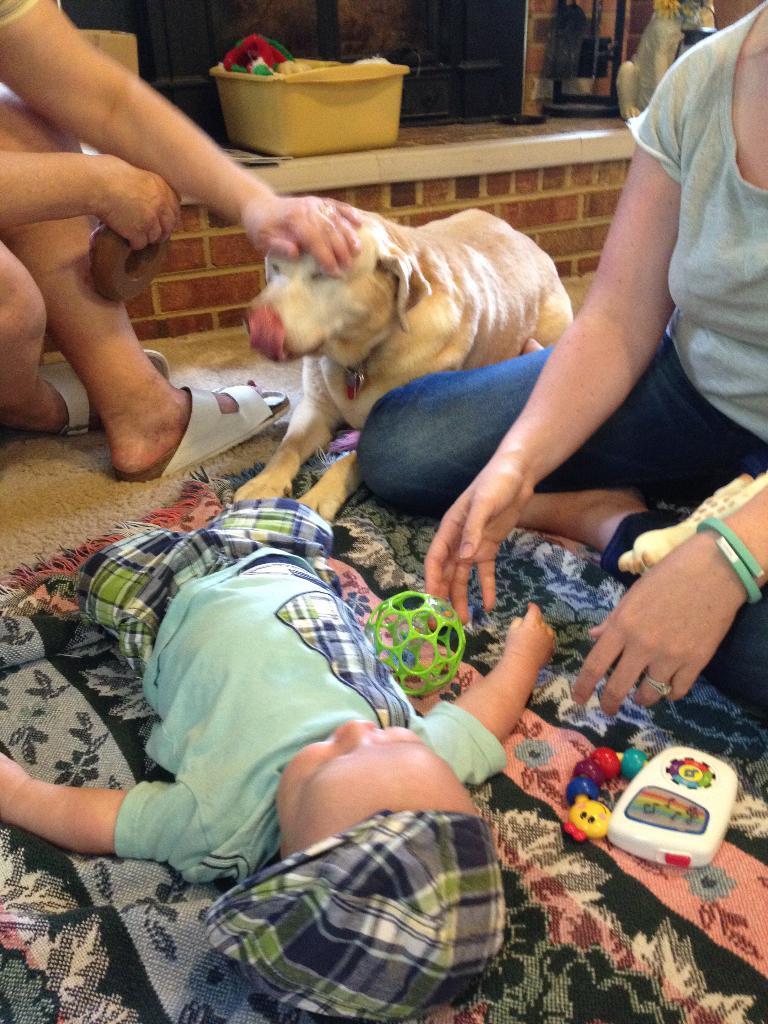In one or two sentences, can you explain what this image depicts? In the background we can see a yellow container and it seems like a cloth in it. On the right side of the picture it seems like a dog on the platform, we can see a woman sitting. In this picture we can see a dog and a person hand is on a dog's head. We can see a baby laying on the blanket and few toys are visible. We can also see the floor carpet. 